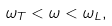<formula> <loc_0><loc_0><loc_500><loc_500>\omega _ { T } < \omega < \omega _ { L } ,</formula> 